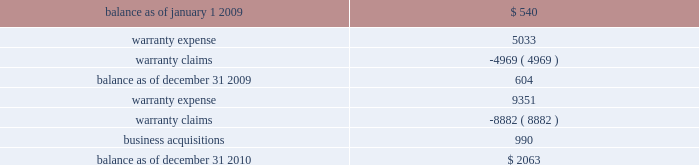On either a straight-line or accelerated basis .
Amortization expense for intangibles was approximately $ 4.2 million , $ 4.1 million and $ 4.1 million during the years ended december 31 , 2010 , 2009 and 2008 , respectively .
Estimated annual amortization expense of the december 31 , 2010 balance for the years ended december 31 , 2011 through 2015 is approximately $ 4.8 million .
Impairment of long-lived assets long-lived assets are reviewed for possible impairment whenever events or circumstances indicate that the carrying amount of such assets may not be recoverable .
If such review indicates that the carrying amount of long- lived assets is not recoverable , the carrying amount of such assets is reduced to fair value .
During the year ended december 31 , 2010 , we recognized impairment charges on certain long-lived assets during the normal course of business of $ 1.3 million .
There were no adjustments to the carrying value of long-lived assets of continuing operations during the years ended december 31 , 2009 or 2008 .
Fair value of financial instruments our debt is reflected on the balance sheet at cost .
Based on market conditions as of december 31 , 2010 , the fair value of our term loans ( see note 5 , 201clong-term obligations 201d ) reasonably approximated the carrying value of $ 590 million .
At december 31 , 2009 , the fair value of our term loans at $ 570 million was below the carrying value of $ 596 million because our interest rate margins were below the rate available in the market .
We estimated the fair value of our term loans by calculating the upfront cash payment a market participant would require to assume our obligations .
The upfront cash payment , excluding any issuance costs , is the amount that a market participant would be able to lend at december 31 , 2010 and 2009 to an entity with a credit rating similar to ours and achieve sufficient cash inflows to cover the scheduled cash outflows under our term loans .
The carrying amounts of our cash and equivalents , net trade receivables and accounts payable approximate fair value .
We apply the market and income approaches to value our financial assets and liabilities , which include the cash surrender value of life insurance , deferred compensation liabilities and interest rate swaps .
Required fair value disclosures are included in note 7 , 201cfair value measurements . 201d product warranties some of our salvage mechanical products are sold with a standard six-month warranty against defects .
Additionally , some of our remanufactured engines are sold with a standard three-year warranty against defects .
We record the estimated warranty costs at the time of sale using historical warranty claim information to project future warranty claims activity and related expenses .
The changes in the warranty reserve are as follows ( in thousands ) : .
Self-insurance reserves we self-insure a portion of employee medical benefits under the terms of our employee health insurance program .
We purchase certain stop-loss insurance to limit our liability exposure .
We also self-insure a portion of .
At december 31 , 2009 what was the difference between the fair value of our term loans to their carrying value in millions? 
Computations: (596 - 570)
Answer: 26.0. 